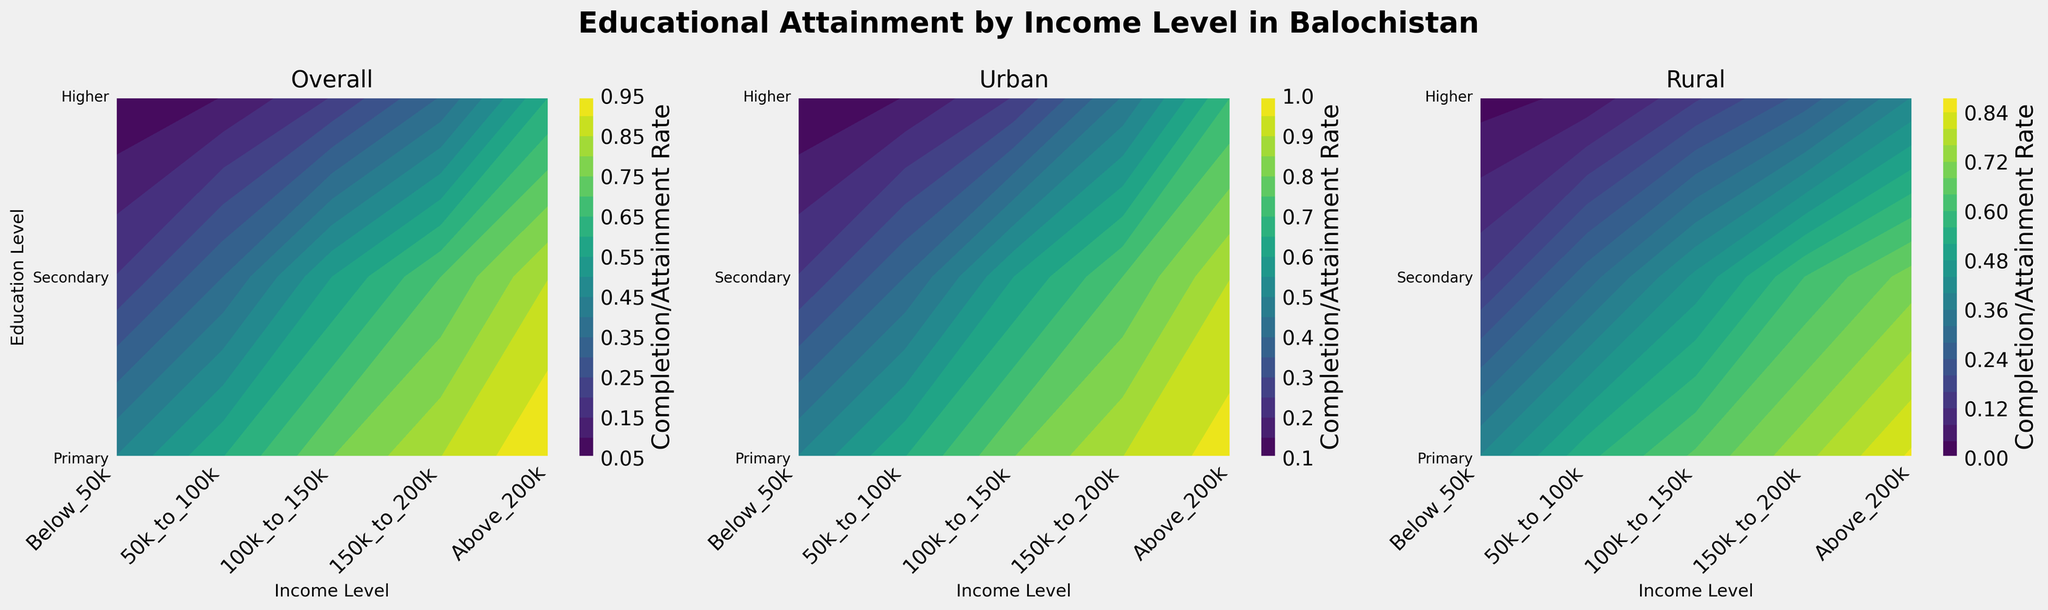How many income levels are represented on the x-axis? The x-axis shows various income levels. Looking at the x-axis labels, there are 'Below_50k', '50k_to_100k', '100k_to_150k', '150k_to_200k', and 'Above_200k', making a total of five income levels.
Answer: Five What is the title of the plot? The title is usually displayed at the top of the plot. Here, it reads 'Educational Attainment by Income Level in Balochistan'.
Answer: Educational Attainment by Income Level in Balochistan How do the educational attainment rates in urban areas for the highest income level compare between primary and higher education? To analyze this, we look at the 'Urban' subplot. For 'Above_200k_Urban', find the color representation for both primary and higher education lines. The color/intensity for primary is at the highest rate (close to 1), whereas for higher education, the rate is slightly lower.
Answer: Primary education rates are higher What is the trend in higher education attainment rates as income levels increase for rural areas? Focus on the 'Rural' subplot and track the higher education line across all income levels from 'Below_50k_Rural' to 'Above_200k_Rural'. As income increases, higher education rates tend to increase consistently.
Answer: Higher education rates increase Which subplot has the highest overall completion/attainment rates across most income levels? Evaluate all three subplots. The 'Urban' subplot generally shows deeper colors for all education levels across income levels compared to the 'Overall' and 'Rural' subplots, indicating higher rates.
Answer: Urban subplot In the 'Overall' subplot, what is the secondary school completion rate for the 100k to 150k income level? Locate the 'Overall' subplot and find where the secondary school line intersects with the '100k_to_150k' income level. The color indicates the rate is around mid-point (0.55).
Answer: Around 0.55 Compare the primary school completion rates between urban and rural areas for the income level 'Below 50k'. Identify the 'Below_50k' income level in both the 'Urban' and 'Rural' subplots and find the corresponding primary school completion rates. Urban has a higher rate than rural.
Answer: Urban is higher What is the higher education attainment rate in rural areas for the lowest income level? Check the 'Rural' subplot at 'Below_50k_Rural' for higher education. The color represents a low rate, around 0.02.
Answer: Around 0.02 How does the overall secondary school completion rate trend as we move from '50k_to_100k' to 'Above_200k'? Trace the secondary school line in the 'Overall' subplot through the income levels from '50k_to_100k' to 'Above_200k'. The completion rate consistently increases.
Answer: It increases In the 'Urban' subplot, which income level shows the largest jump in completion rates from primary to higher education? Compare the difference between primary and higher education rates for each income level in the 'Urban' subplot. '150k_to_200k_Urban' shows a significant jump from around primary to higher.
Answer: '150k_to_200k_Urban' 